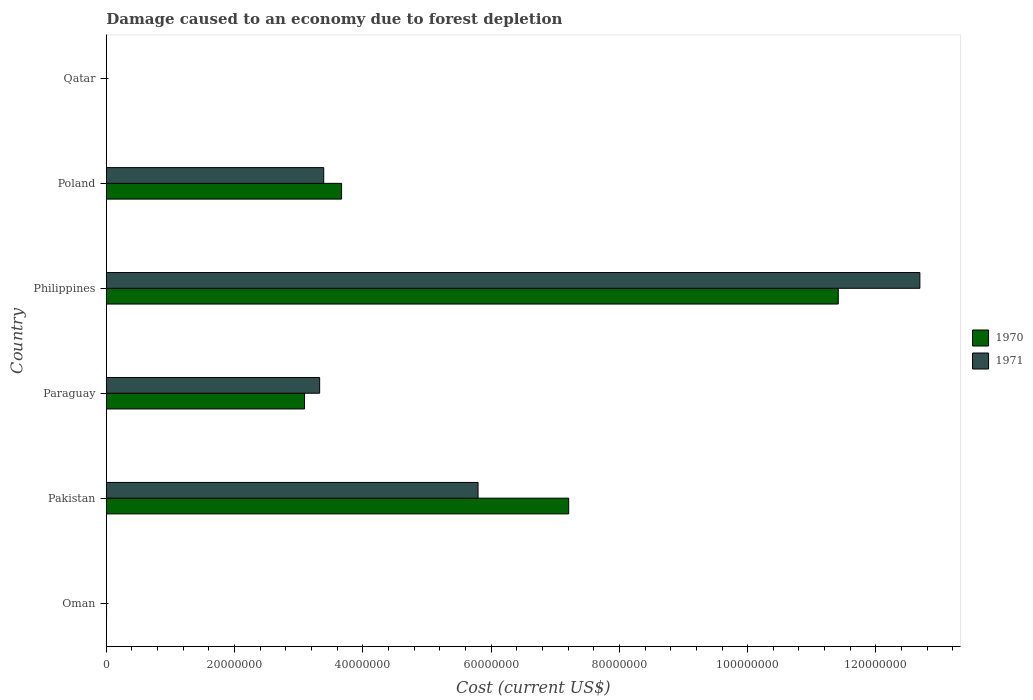How many different coloured bars are there?
Ensure brevity in your answer.  2. How many groups of bars are there?
Your answer should be very brief. 6. Are the number of bars per tick equal to the number of legend labels?
Provide a short and direct response. Yes. Are the number of bars on each tick of the Y-axis equal?
Your answer should be compact. Yes. What is the cost of damage caused due to forest depletion in 1970 in Pakistan?
Offer a terse response. 7.21e+07. Across all countries, what is the maximum cost of damage caused due to forest depletion in 1971?
Give a very brief answer. 1.27e+08. Across all countries, what is the minimum cost of damage caused due to forest depletion in 1971?
Ensure brevity in your answer.  1827.27. In which country was the cost of damage caused due to forest depletion in 1970 maximum?
Offer a terse response. Philippines. In which country was the cost of damage caused due to forest depletion in 1971 minimum?
Your response must be concise. Qatar. What is the total cost of damage caused due to forest depletion in 1970 in the graph?
Provide a succinct answer. 2.54e+08. What is the difference between the cost of damage caused due to forest depletion in 1971 in Philippines and that in Qatar?
Offer a terse response. 1.27e+08. What is the difference between the cost of damage caused due to forest depletion in 1971 in Qatar and the cost of damage caused due to forest depletion in 1970 in Paraguay?
Provide a succinct answer. -3.09e+07. What is the average cost of damage caused due to forest depletion in 1970 per country?
Ensure brevity in your answer.  4.23e+07. What is the difference between the cost of damage caused due to forest depletion in 1971 and cost of damage caused due to forest depletion in 1970 in Poland?
Your answer should be compact. -2.78e+06. What is the ratio of the cost of damage caused due to forest depletion in 1971 in Pakistan to that in Philippines?
Your answer should be very brief. 0.46. Is the cost of damage caused due to forest depletion in 1971 in Philippines less than that in Qatar?
Offer a very short reply. No. Is the difference between the cost of damage caused due to forest depletion in 1971 in Paraguay and Philippines greater than the difference between the cost of damage caused due to forest depletion in 1970 in Paraguay and Philippines?
Keep it short and to the point. No. What is the difference between the highest and the second highest cost of damage caused due to forest depletion in 1971?
Ensure brevity in your answer.  6.89e+07. What is the difference between the highest and the lowest cost of damage caused due to forest depletion in 1970?
Give a very brief answer. 1.14e+08. What does the 1st bar from the top in Philippines represents?
Provide a succinct answer. 1971. What does the 2nd bar from the bottom in Paraguay represents?
Your answer should be very brief. 1971. Are all the bars in the graph horizontal?
Keep it short and to the point. Yes. What is the difference between two consecutive major ticks on the X-axis?
Provide a succinct answer. 2.00e+07. Are the values on the major ticks of X-axis written in scientific E-notation?
Offer a very short reply. No. Does the graph contain grids?
Keep it short and to the point. No. How are the legend labels stacked?
Make the answer very short. Vertical. What is the title of the graph?
Your answer should be very brief. Damage caused to an economy due to forest depletion. What is the label or title of the X-axis?
Offer a very short reply. Cost (current US$). What is the label or title of the Y-axis?
Provide a short and direct response. Country. What is the Cost (current US$) of 1970 in Oman?
Keep it short and to the point. 3.33e+04. What is the Cost (current US$) in 1971 in Oman?
Ensure brevity in your answer.  2.65e+04. What is the Cost (current US$) of 1970 in Pakistan?
Make the answer very short. 7.21e+07. What is the Cost (current US$) of 1971 in Pakistan?
Your response must be concise. 5.80e+07. What is the Cost (current US$) in 1970 in Paraguay?
Your answer should be very brief. 3.09e+07. What is the Cost (current US$) in 1971 in Paraguay?
Your response must be concise. 3.33e+07. What is the Cost (current US$) in 1970 in Philippines?
Your answer should be compact. 1.14e+08. What is the Cost (current US$) in 1971 in Philippines?
Provide a succinct answer. 1.27e+08. What is the Cost (current US$) of 1970 in Poland?
Offer a very short reply. 3.67e+07. What is the Cost (current US$) of 1971 in Poland?
Make the answer very short. 3.39e+07. What is the Cost (current US$) of 1970 in Qatar?
Ensure brevity in your answer.  2983.61. What is the Cost (current US$) in 1971 in Qatar?
Ensure brevity in your answer.  1827.27. Across all countries, what is the maximum Cost (current US$) in 1970?
Make the answer very short. 1.14e+08. Across all countries, what is the maximum Cost (current US$) of 1971?
Offer a very short reply. 1.27e+08. Across all countries, what is the minimum Cost (current US$) in 1970?
Keep it short and to the point. 2983.61. Across all countries, what is the minimum Cost (current US$) of 1971?
Make the answer very short. 1827.27. What is the total Cost (current US$) in 1970 in the graph?
Offer a very short reply. 2.54e+08. What is the total Cost (current US$) of 1971 in the graph?
Keep it short and to the point. 2.52e+08. What is the difference between the Cost (current US$) in 1970 in Oman and that in Pakistan?
Keep it short and to the point. -7.21e+07. What is the difference between the Cost (current US$) of 1971 in Oman and that in Pakistan?
Keep it short and to the point. -5.79e+07. What is the difference between the Cost (current US$) of 1970 in Oman and that in Paraguay?
Make the answer very short. -3.09e+07. What is the difference between the Cost (current US$) of 1971 in Oman and that in Paraguay?
Make the answer very short. -3.32e+07. What is the difference between the Cost (current US$) in 1970 in Oman and that in Philippines?
Offer a very short reply. -1.14e+08. What is the difference between the Cost (current US$) of 1971 in Oman and that in Philippines?
Your response must be concise. -1.27e+08. What is the difference between the Cost (current US$) in 1970 in Oman and that in Poland?
Offer a very short reply. -3.66e+07. What is the difference between the Cost (current US$) of 1971 in Oman and that in Poland?
Provide a short and direct response. -3.39e+07. What is the difference between the Cost (current US$) of 1970 in Oman and that in Qatar?
Your answer should be compact. 3.03e+04. What is the difference between the Cost (current US$) of 1971 in Oman and that in Qatar?
Provide a succinct answer. 2.47e+04. What is the difference between the Cost (current US$) of 1970 in Pakistan and that in Paraguay?
Your answer should be very brief. 4.12e+07. What is the difference between the Cost (current US$) in 1971 in Pakistan and that in Paraguay?
Your response must be concise. 2.47e+07. What is the difference between the Cost (current US$) in 1970 in Pakistan and that in Philippines?
Your answer should be compact. -4.20e+07. What is the difference between the Cost (current US$) in 1971 in Pakistan and that in Philippines?
Give a very brief answer. -6.89e+07. What is the difference between the Cost (current US$) in 1970 in Pakistan and that in Poland?
Offer a very short reply. 3.54e+07. What is the difference between the Cost (current US$) in 1971 in Pakistan and that in Poland?
Your answer should be very brief. 2.41e+07. What is the difference between the Cost (current US$) in 1970 in Pakistan and that in Qatar?
Provide a short and direct response. 7.21e+07. What is the difference between the Cost (current US$) in 1971 in Pakistan and that in Qatar?
Your answer should be very brief. 5.80e+07. What is the difference between the Cost (current US$) in 1970 in Paraguay and that in Philippines?
Your answer should be very brief. -8.32e+07. What is the difference between the Cost (current US$) in 1971 in Paraguay and that in Philippines?
Your answer should be very brief. -9.36e+07. What is the difference between the Cost (current US$) in 1970 in Paraguay and that in Poland?
Provide a succinct answer. -5.78e+06. What is the difference between the Cost (current US$) in 1971 in Paraguay and that in Poland?
Provide a short and direct response. -6.33e+05. What is the difference between the Cost (current US$) of 1970 in Paraguay and that in Qatar?
Ensure brevity in your answer.  3.09e+07. What is the difference between the Cost (current US$) in 1971 in Paraguay and that in Qatar?
Ensure brevity in your answer.  3.33e+07. What is the difference between the Cost (current US$) in 1970 in Philippines and that in Poland?
Offer a very short reply. 7.75e+07. What is the difference between the Cost (current US$) of 1971 in Philippines and that in Poland?
Ensure brevity in your answer.  9.30e+07. What is the difference between the Cost (current US$) in 1970 in Philippines and that in Qatar?
Your answer should be compact. 1.14e+08. What is the difference between the Cost (current US$) in 1971 in Philippines and that in Qatar?
Your response must be concise. 1.27e+08. What is the difference between the Cost (current US$) of 1970 in Poland and that in Qatar?
Offer a terse response. 3.67e+07. What is the difference between the Cost (current US$) of 1971 in Poland and that in Qatar?
Offer a very short reply. 3.39e+07. What is the difference between the Cost (current US$) in 1970 in Oman and the Cost (current US$) in 1971 in Pakistan?
Give a very brief answer. -5.79e+07. What is the difference between the Cost (current US$) of 1970 in Oman and the Cost (current US$) of 1971 in Paraguay?
Give a very brief answer. -3.32e+07. What is the difference between the Cost (current US$) in 1970 in Oman and the Cost (current US$) in 1971 in Philippines?
Provide a short and direct response. -1.27e+08. What is the difference between the Cost (current US$) in 1970 in Oman and the Cost (current US$) in 1971 in Poland?
Your response must be concise. -3.39e+07. What is the difference between the Cost (current US$) in 1970 in Oman and the Cost (current US$) in 1971 in Qatar?
Your response must be concise. 3.15e+04. What is the difference between the Cost (current US$) in 1970 in Pakistan and the Cost (current US$) in 1971 in Paraguay?
Provide a short and direct response. 3.88e+07. What is the difference between the Cost (current US$) of 1970 in Pakistan and the Cost (current US$) of 1971 in Philippines?
Provide a short and direct response. -5.48e+07. What is the difference between the Cost (current US$) in 1970 in Pakistan and the Cost (current US$) in 1971 in Poland?
Make the answer very short. 3.82e+07. What is the difference between the Cost (current US$) in 1970 in Pakistan and the Cost (current US$) in 1971 in Qatar?
Provide a succinct answer. 7.21e+07. What is the difference between the Cost (current US$) of 1970 in Paraguay and the Cost (current US$) of 1971 in Philippines?
Make the answer very short. -9.60e+07. What is the difference between the Cost (current US$) of 1970 in Paraguay and the Cost (current US$) of 1971 in Poland?
Give a very brief answer. -3.00e+06. What is the difference between the Cost (current US$) of 1970 in Paraguay and the Cost (current US$) of 1971 in Qatar?
Your answer should be very brief. 3.09e+07. What is the difference between the Cost (current US$) in 1970 in Philippines and the Cost (current US$) in 1971 in Poland?
Make the answer very short. 8.02e+07. What is the difference between the Cost (current US$) of 1970 in Philippines and the Cost (current US$) of 1971 in Qatar?
Offer a very short reply. 1.14e+08. What is the difference between the Cost (current US$) of 1970 in Poland and the Cost (current US$) of 1971 in Qatar?
Your answer should be very brief. 3.67e+07. What is the average Cost (current US$) of 1970 per country?
Offer a very short reply. 4.23e+07. What is the average Cost (current US$) in 1971 per country?
Offer a terse response. 4.20e+07. What is the difference between the Cost (current US$) of 1970 and Cost (current US$) of 1971 in Oman?
Provide a succinct answer. 6781.75. What is the difference between the Cost (current US$) in 1970 and Cost (current US$) in 1971 in Pakistan?
Your response must be concise. 1.41e+07. What is the difference between the Cost (current US$) of 1970 and Cost (current US$) of 1971 in Paraguay?
Give a very brief answer. -2.36e+06. What is the difference between the Cost (current US$) in 1970 and Cost (current US$) in 1971 in Philippines?
Keep it short and to the point. -1.27e+07. What is the difference between the Cost (current US$) of 1970 and Cost (current US$) of 1971 in Poland?
Provide a short and direct response. 2.78e+06. What is the difference between the Cost (current US$) in 1970 and Cost (current US$) in 1971 in Qatar?
Your answer should be compact. 1156.35. What is the ratio of the Cost (current US$) of 1971 in Oman to that in Pakistan?
Ensure brevity in your answer.  0. What is the ratio of the Cost (current US$) in 1970 in Oman to that in Paraguay?
Keep it short and to the point. 0. What is the ratio of the Cost (current US$) of 1971 in Oman to that in Paraguay?
Provide a succinct answer. 0. What is the ratio of the Cost (current US$) in 1970 in Oman to that in Philippines?
Offer a very short reply. 0. What is the ratio of the Cost (current US$) of 1970 in Oman to that in Poland?
Make the answer very short. 0. What is the ratio of the Cost (current US$) in 1971 in Oman to that in Poland?
Your answer should be very brief. 0. What is the ratio of the Cost (current US$) in 1970 in Oman to that in Qatar?
Your answer should be very brief. 11.16. What is the ratio of the Cost (current US$) in 1971 in Oman to that in Qatar?
Your response must be concise. 14.52. What is the ratio of the Cost (current US$) in 1970 in Pakistan to that in Paraguay?
Make the answer very short. 2.33. What is the ratio of the Cost (current US$) in 1971 in Pakistan to that in Paraguay?
Give a very brief answer. 1.74. What is the ratio of the Cost (current US$) in 1970 in Pakistan to that in Philippines?
Provide a succinct answer. 0.63. What is the ratio of the Cost (current US$) of 1971 in Pakistan to that in Philippines?
Provide a succinct answer. 0.46. What is the ratio of the Cost (current US$) in 1970 in Pakistan to that in Poland?
Ensure brevity in your answer.  1.97. What is the ratio of the Cost (current US$) in 1971 in Pakistan to that in Poland?
Give a very brief answer. 1.71. What is the ratio of the Cost (current US$) in 1970 in Pakistan to that in Qatar?
Provide a succinct answer. 2.42e+04. What is the ratio of the Cost (current US$) of 1971 in Pakistan to that in Qatar?
Ensure brevity in your answer.  3.17e+04. What is the ratio of the Cost (current US$) in 1970 in Paraguay to that in Philippines?
Your answer should be compact. 0.27. What is the ratio of the Cost (current US$) in 1971 in Paraguay to that in Philippines?
Offer a terse response. 0.26. What is the ratio of the Cost (current US$) in 1970 in Paraguay to that in Poland?
Give a very brief answer. 0.84. What is the ratio of the Cost (current US$) of 1971 in Paraguay to that in Poland?
Make the answer very short. 0.98. What is the ratio of the Cost (current US$) in 1970 in Paraguay to that in Qatar?
Your answer should be compact. 1.04e+04. What is the ratio of the Cost (current US$) in 1971 in Paraguay to that in Qatar?
Offer a terse response. 1.82e+04. What is the ratio of the Cost (current US$) in 1970 in Philippines to that in Poland?
Ensure brevity in your answer.  3.11. What is the ratio of the Cost (current US$) of 1971 in Philippines to that in Poland?
Offer a terse response. 3.74. What is the ratio of the Cost (current US$) of 1970 in Philippines to that in Qatar?
Ensure brevity in your answer.  3.83e+04. What is the ratio of the Cost (current US$) of 1971 in Philippines to that in Qatar?
Your answer should be compact. 6.94e+04. What is the ratio of the Cost (current US$) of 1970 in Poland to that in Qatar?
Your answer should be very brief. 1.23e+04. What is the ratio of the Cost (current US$) of 1971 in Poland to that in Qatar?
Your response must be concise. 1.86e+04. What is the difference between the highest and the second highest Cost (current US$) of 1970?
Make the answer very short. 4.20e+07. What is the difference between the highest and the second highest Cost (current US$) of 1971?
Give a very brief answer. 6.89e+07. What is the difference between the highest and the lowest Cost (current US$) in 1970?
Provide a short and direct response. 1.14e+08. What is the difference between the highest and the lowest Cost (current US$) in 1971?
Make the answer very short. 1.27e+08. 